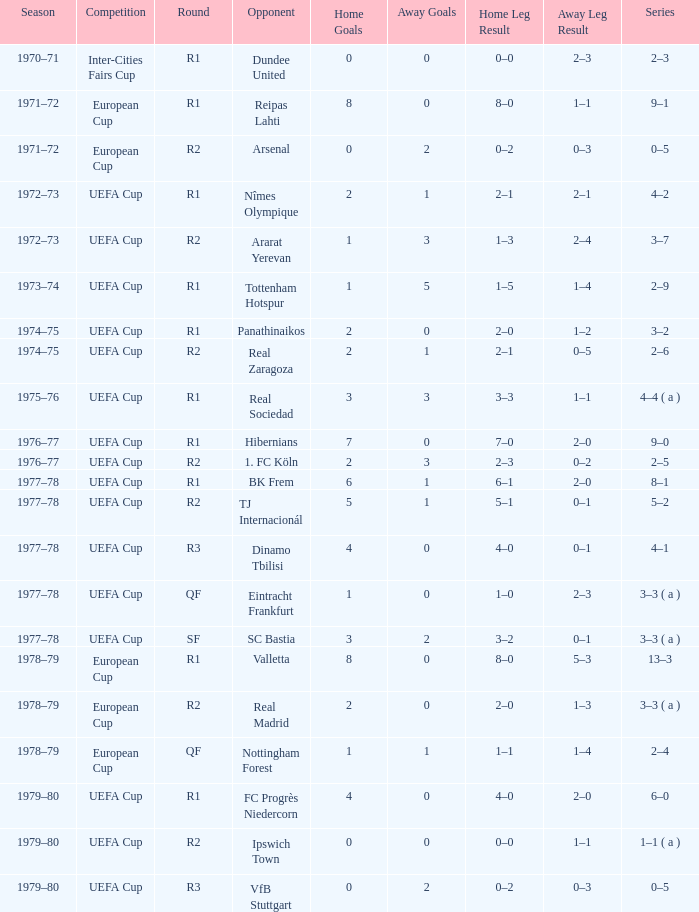In which round of the uefa cup does a competition with a series of 5-2 occur? R2. 